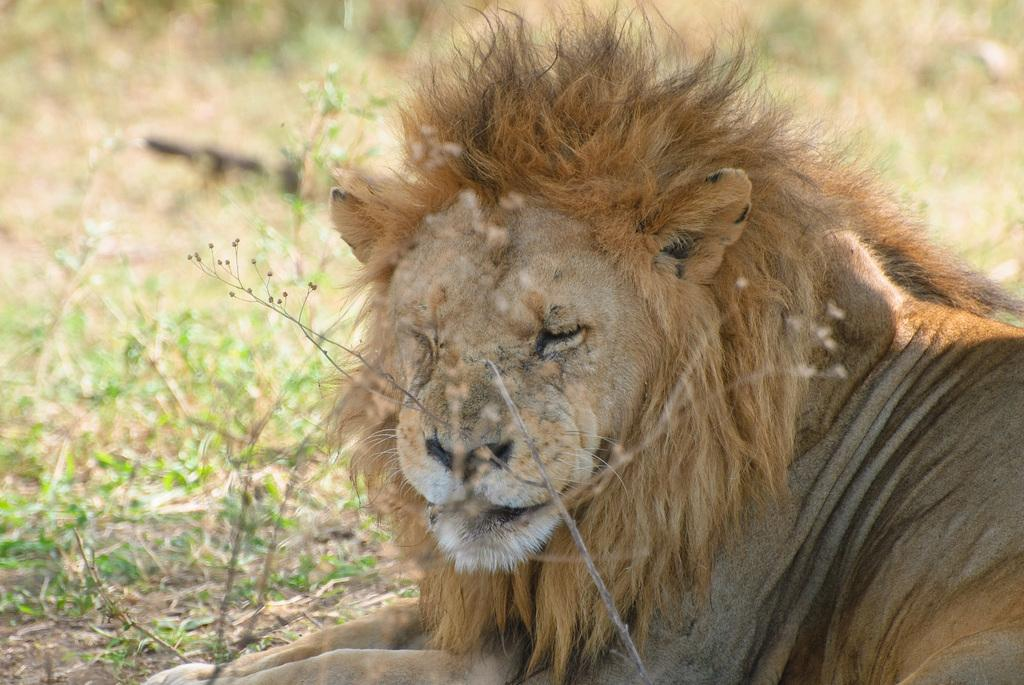What type of animal is in the image? There is a lion in the image. What type of comb is the lion using in the image? There is no comb present in the image, as lions do not use combs. 